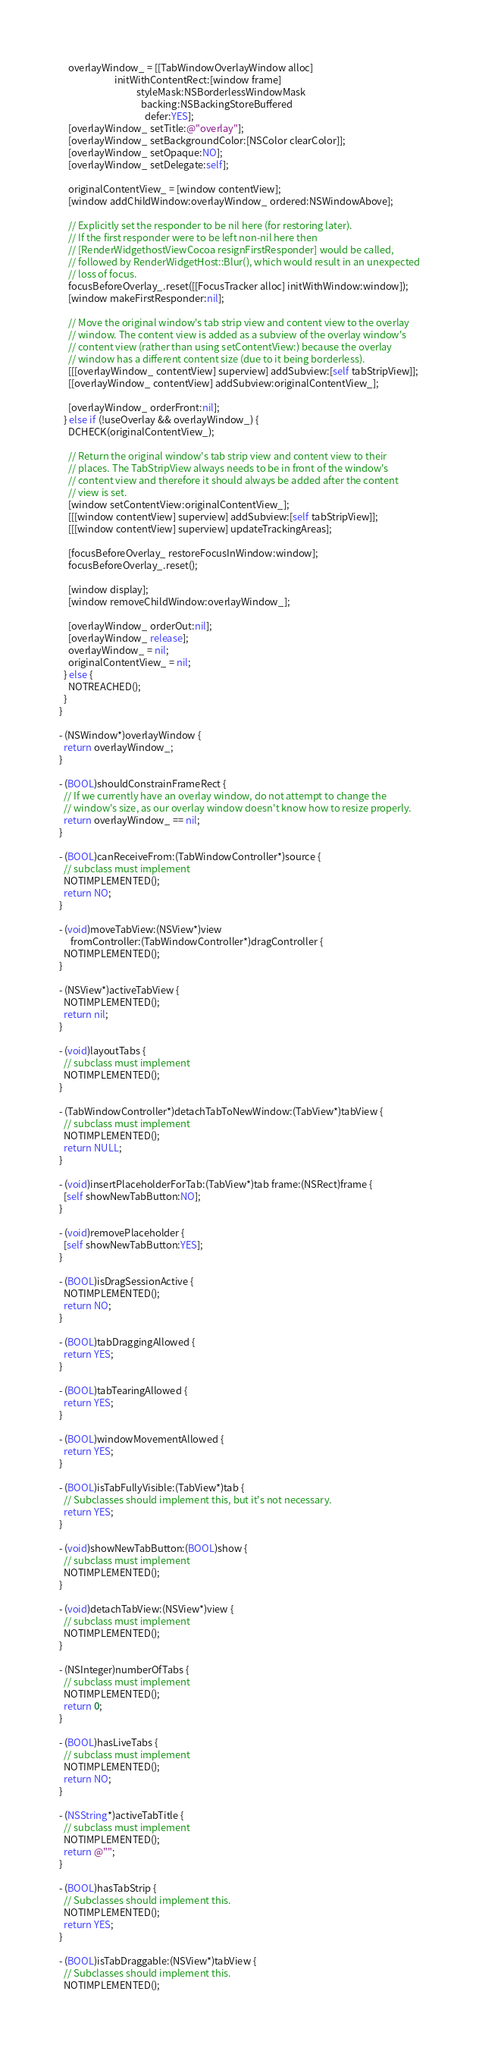Convert code to text. <code><loc_0><loc_0><loc_500><loc_500><_ObjectiveC_>
    overlayWindow_ = [[TabWindowOverlayWindow alloc]
                         initWithContentRect:[window frame]
                                   styleMask:NSBorderlessWindowMask
                                     backing:NSBackingStoreBuffered
                                       defer:YES];
    [overlayWindow_ setTitle:@"overlay"];
    [overlayWindow_ setBackgroundColor:[NSColor clearColor]];
    [overlayWindow_ setOpaque:NO];
    [overlayWindow_ setDelegate:self];

    originalContentView_ = [window contentView];
    [window addChildWindow:overlayWindow_ ordered:NSWindowAbove];

    // Explicitly set the responder to be nil here (for restoring later).
    // If the first responder were to be left non-nil here then
    // [RenderWidgethostViewCocoa resignFirstResponder] would be called,
    // followed by RenderWidgetHost::Blur(), which would result in an unexpected
    // loss of focus.
    focusBeforeOverlay_.reset([[FocusTracker alloc] initWithWindow:window]);
    [window makeFirstResponder:nil];

    // Move the original window's tab strip view and content view to the overlay
    // window. The content view is added as a subview of the overlay window's
    // content view (rather than using setContentView:) because the overlay
    // window has a different content size (due to it being borderless).
    [[[overlayWindow_ contentView] superview] addSubview:[self tabStripView]];
    [[overlayWindow_ contentView] addSubview:originalContentView_];

    [overlayWindow_ orderFront:nil];
  } else if (!useOverlay && overlayWindow_) {
    DCHECK(originalContentView_);

    // Return the original window's tab strip view and content view to their
    // places. The TabStripView always needs to be in front of the window's
    // content view and therefore it should always be added after the content
    // view is set.
    [window setContentView:originalContentView_];
    [[[window contentView] superview] addSubview:[self tabStripView]];
    [[[window contentView] superview] updateTrackingAreas];

    [focusBeforeOverlay_ restoreFocusInWindow:window];
    focusBeforeOverlay_.reset();

    [window display];
    [window removeChildWindow:overlayWindow_];

    [overlayWindow_ orderOut:nil];
    [overlayWindow_ release];
    overlayWindow_ = nil;
    originalContentView_ = nil;
  } else {
    NOTREACHED();
  }
}

- (NSWindow*)overlayWindow {
  return overlayWindow_;
}

- (BOOL)shouldConstrainFrameRect {
  // If we currently have an overlay window, do not attempt to change the
  // window's size, as our overlay window doesn't know how to resize properly.
  return overlayWindow_ == nil;
}

- (BOOL)canReceiveFrom:(TabWindowController*)source {
  // subclass must implement
  NOTIMPLEMENTED();
  return NO;
}

- (void)moveTabView:(NSView*)view
     fromController:(TabWindowController*)dragController {
  NOTIMPLEMENTED();
}

- (NSView*)activeTabView {
  NOTIMPLEMENTED();
  return nil;
}

- (void)layoutTabs {
  // subclass must implement
  NOTIMPLEMENTED();
}

- (TabWindowController*)detachTabToNewWindow:(TabView*)tabView {
  // subclass must implement
  NOTIMPLEMENTED();
  return NULL;
}

- (void)insertPlaceholderForTab:(TabView*)tab frame:(NSRect)frame {
  [self showNewTabButton:NO];
}

- (void)removePlaceholder {
  [self showNewTabButton:YES];
}

- (BOOL)isDragSessionActive {
  NOTIMPLEMENTED();
  return NO;
}

- (BOOL)tabDraggingAllowed {
  return YES;
}

- (BOOL)tabTearingAllowed {
  return YES;
}

- (BOOL)windowMovementAllowed {
  return YES;
}

- (BOOL)isTabFullyVisible:(TabView*)tab {
  // Subclasses should implement this, but it's not necessary.
  return YES;
}

- (void)showNewTabButton:(BOOL)show {
  // subclass must implement
  NOTIMPLEMENTED();
}

- (void)detachTabView:(NSView*)view {
  // subclass must implement
  NOTIMPLEMENTED();
}

- (NSInteger)numberOfTabs {
  // subclass must implement
  NOTIMPLEMENTED();
  return 0;
}

- (BOOL)hasLiveTabs {
  // subclass must implement
  NOTIMPLEMENTED();
  return NO;
}

- (NSString*)activeTabTitle {
  // subclass must implement
  NOTIMPLEMENTED();
  return @"";
}

- (BOOL)hasTabStrip {
  // Subclasses should implement this.
  NOTIMPLEMENTED();
  return YES;
}

- (BOOL)isTabDraggable:(NSView*)tabView {
  // Subclasses should implement this.
  NOTIMPLEMENTED();</code> 